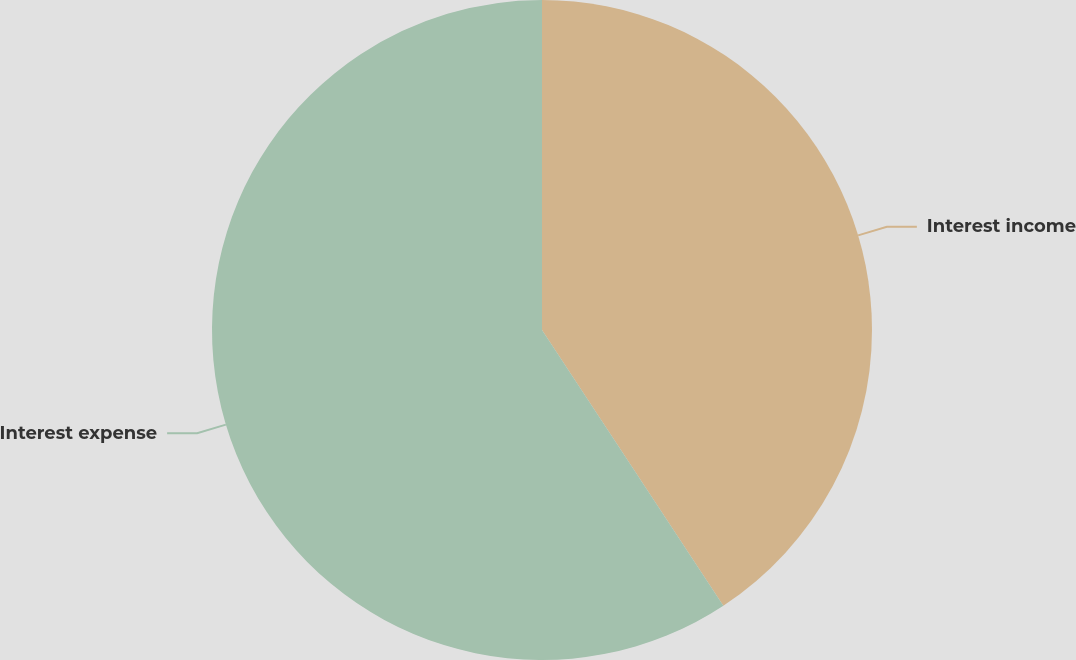Convert chart. <chart><loc_0><loc_0><loc_500><loc_500><pie_chart><fcel>Interest income<fcel>Interest expense<nl><fcel>40.74%<fcel>59.26%<nl></chart> 